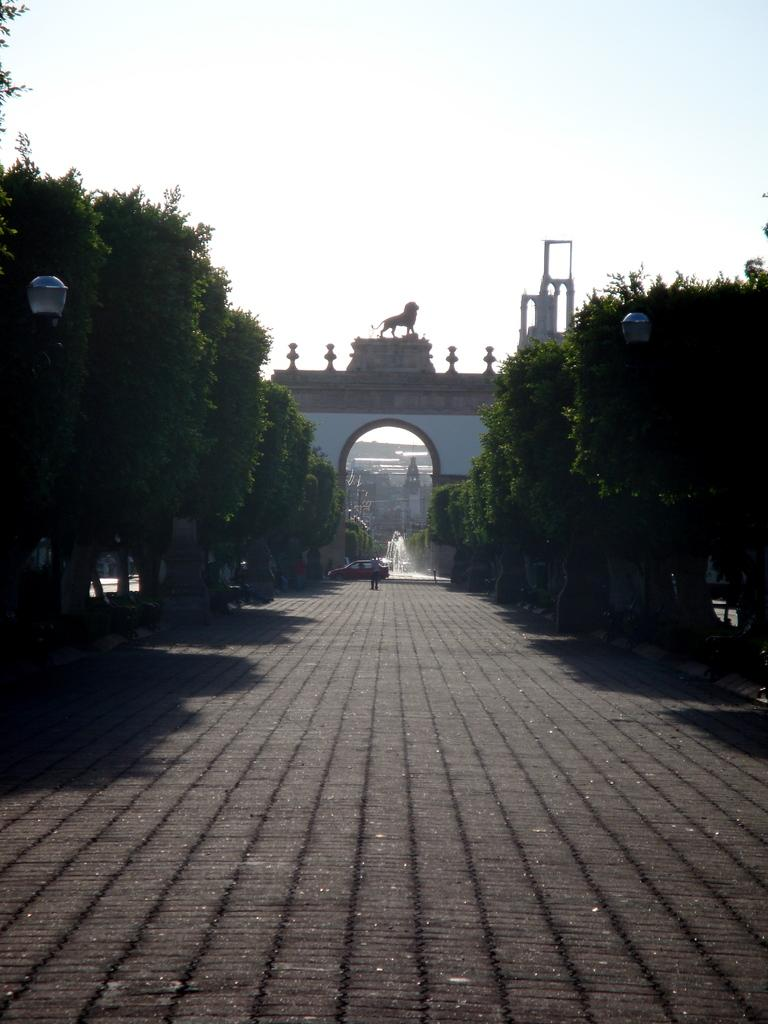What can be seen in the foreground of the image? There is a path in the foreground of the image. What type of vegetation is present around the path? Trees are present around the path. What is located in the background of the image? There is an arch in the background of the image. What is situated under the arch? A fountain is located under the arch. How many cakes are displayed on the cactus in the image? There is no cactus or cakes present in the image. 